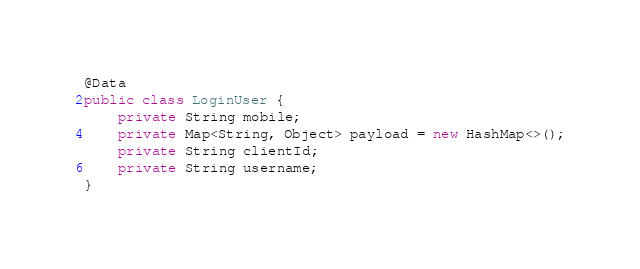<code> <loc_0><loc_0><loc_500><loc_500><_Java_>
@Data
public class LoginUser {
	private String mobile;
	private Map<String, Object> payload = new HashMap<>();
	private String clientId;
	private String username;
}
</code> 